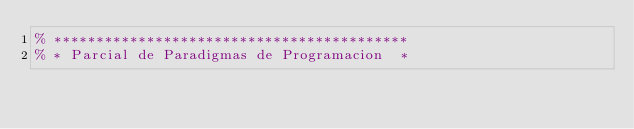<code> <loc_0><loc_0><loc_500><loc_500><_Prolog_>% ******************************************
% * Parcial de Paradigmas de Programacion  *</code> 